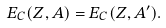Convert formula to latex. <formula><loc_0><loc_0><loc_500><loc_500>E _ { C } ( Z , A ) = E _ { C } ( Z , A ^ { \prime } ) .</formula> 